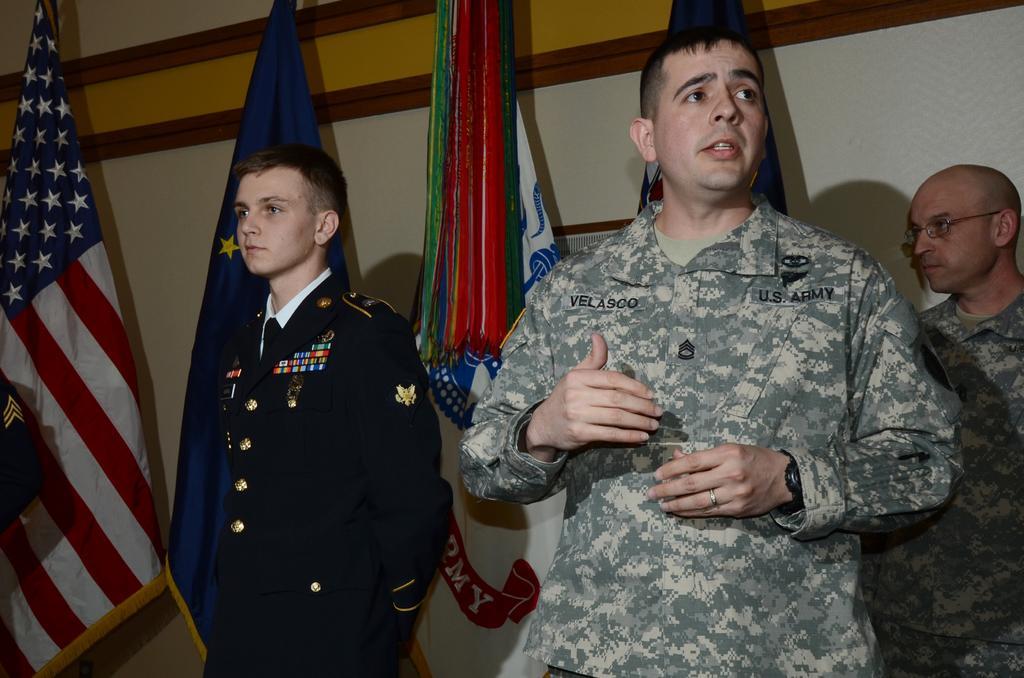Can you describe this image briefly? In this image there are three men standing towards the bottom of the image, there is a man talking, there are flags, at the background of the image there is a wall. 